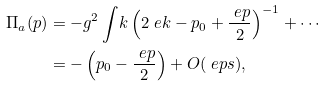Convert formula to latex. <formula><loc_0><loc_0><loc_500><loc_500>\Pi _ { a } ( p ) & = - g ^ { 2 } \int _ { \ } k \left ( 2 \ e k - p _ { 0 } + \frac { \ e p } 2 \right ) ^ { - 1 } + \cdots \\ & = - \left ( p _ { 0 } - \frac { \ e p } 2 \right ) + O ( \ e p s ) ,</formula> 